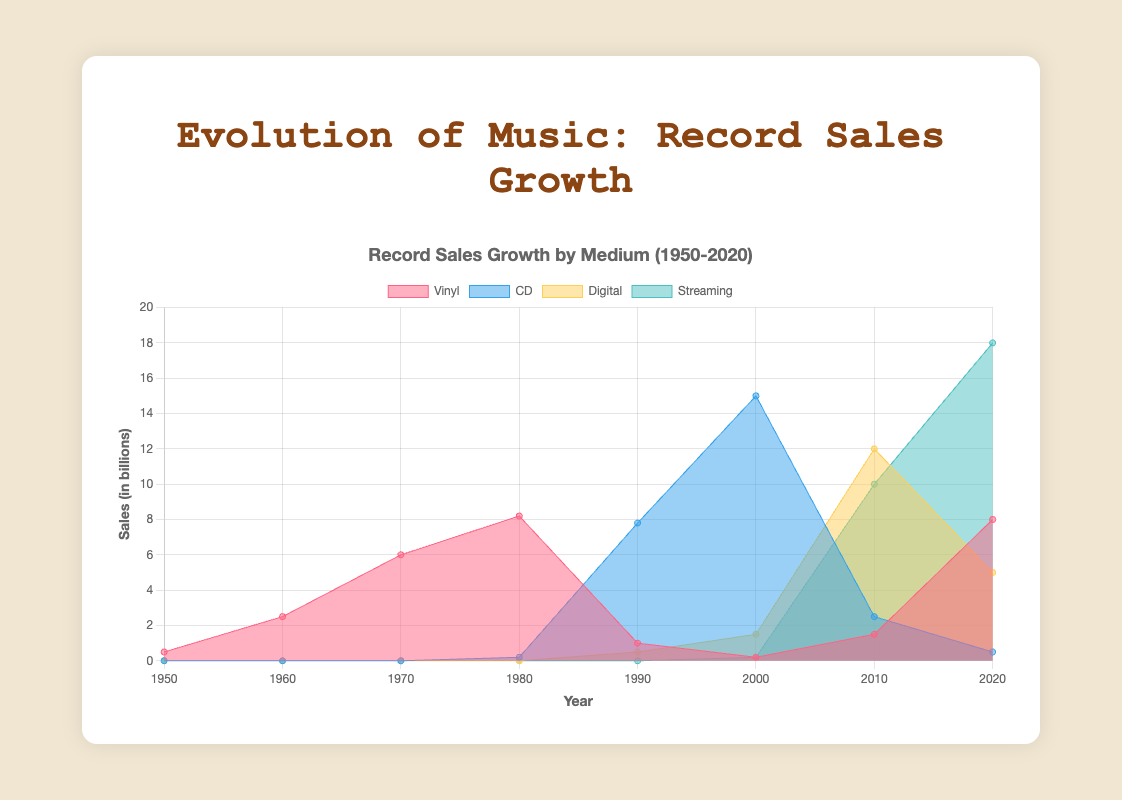What is the title of the figure? The title can be found at the top of the figure. It provides a summary of what the data represents.
Answer: Record Sales Growth by Medium (1950-2020) What is the maximum value for Streaming sales? Look for the highest data point in the Streaming area. This occurs at the year 2020 with a value of 18.0 billion.
Answer: 18.0 billion Which medium shows an increasing trend after 2000? By observing the area chart post-2000, you see that Streaming and Digital both display an upward trend, but Streaming has a more pronounced and consistent increase.
Answer: Streaming How many different colors are used to represent the data for different media? Count the distinct filled colors in the chart, each representing a different medium. There are four colors used for Vinyl, CD, Digital, and Streaming.
Answer: Four In which decade did CD sales peak? Find the highest point in the area representing CD sales. This peak occurs around the 2000s.
Answer: 2000s What was the approximate value of Vinyl sales in 1980 and how does it compare to Digital sales in 2010? Vinyl sales in 1980 were about 8.2 billion, and Digital sales in 2010 were approximately 12.0 billion. Comparing these, we see that Digital sales in 2010 were higher.
Answer: Vinyl: 8.2 billion, Digital: 12.0 billion, Digital higher Between which two decades did Vinyl sales see the largest decrease? Identify the two decades where the Vinyl sales dropped the most, which occurred between 1980 (8.2 billion) and 1990 (1.0 billion), a decrease of 7.2 billion.
Answer: Between 1980 and 1990 Which medium had no sales recorded in the 1950s? Look for the medium with an area value of zero in the 1950s. CDs, Digital, and Streaming all had no sales in the 1950s according to the chart.
Answer: CD, Digital, Streaming What is the combined total of Vinyl and CD sales in 1990? Add the values of Vinyl (1.0 billion) and CD (7.8 billion) sales in 1990. The total is 1.0 + 7.8 = 8.8 billion.
Answer: 8.8 billion What is the trend for Digital sales between 2010 and 2020? Observe the area representing Digital sales from 2010 to 2020. It shows a decline from 12.0 billion in 2010 to 5.0 billion in 2020.
Answer: Declining 